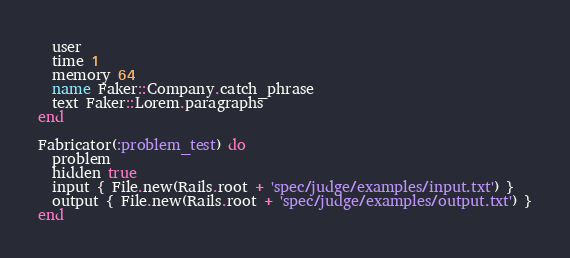Convert code to text. <code><loc_0><loc_0><loc_500><loc_500><_Ruby_>  user
  time 1
  memory 64
  name Faker::Company.catch_phrase
  text Faker::Lorem.paragraphs
end

Fabricator(:problem_test) do
  problem
  hidden true
  input { File.new(Rails.root + 'spec/judge/examples/input.txt') }
  output { File.new(Rails.root + 'spec/judge/examples/output.txt') }
end
</code> 